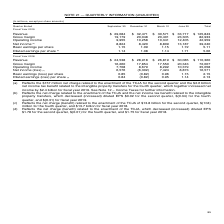According to Microsoft Corporation's financial document, What does Note 12 cover? According to the financial document, Income Taxes. The relevant text states: "$2.4 billion for fiscal year 2019. See Note 12 – Income Taxes for further information...." Also, How much was the net charge related to the enactment of the TCJA for the second quarter? $157 million net charge related to the enactment of the TCJA for the second quarter. The document states: "(a) Reflects the $157 million net charge related to the enactment of the TCJA for the second quarter and the $2.6 billion net income tax benefit relat..." Also, What does Note 21 cover? QUARTERLY INFORMATION (UNAUDITED). The document states: "NOTE 21 — QUARTERLY INFORMATION (UNAUDITED)..." Additionally, Which quarter ended in fiscal year 2019 saw the highest revenue? According to the financial document, June 30. The relevant text states: "Quarter Ended September 30 December 31 March 31 June 30 Total..." Also, can you calculate: How much would diluted EPS be for second quarter ended of fiscal year 2019 without the net charge related to the enactment of the TCJA and the net income tax benefit related to the intangible property transfers? Based on the calculation: 1.71+0.02, the result is 1.73. This is based on the information: "Diluted earnings per share (b) 1.14 1.08 1.14 1.71 5.06 ansfers, which decreased (increased) diluted EPS $0.02 for the second quarter, $(0.34) for the fourth quarter, and $(0.31) for fiscal year 2019...." The key data points involved are: 0.02, 1.71. Also, can you calculate: How much would diluted earnings per share for fiscal year 2018 be without the net charge (benefit) related to the enactment of the TCJA? Based on the calculation: 2.13+1.75, the result is 3.88. This is based on the information: "rnings (loss) per share (d) 0.84 (0.82) 0.95 1.14 2.13 ond quarter, $(0.01) for the fourth quarter, and $1.75 for fiscal year 2018...." The key data points involved are: 1.75, 2.13. 